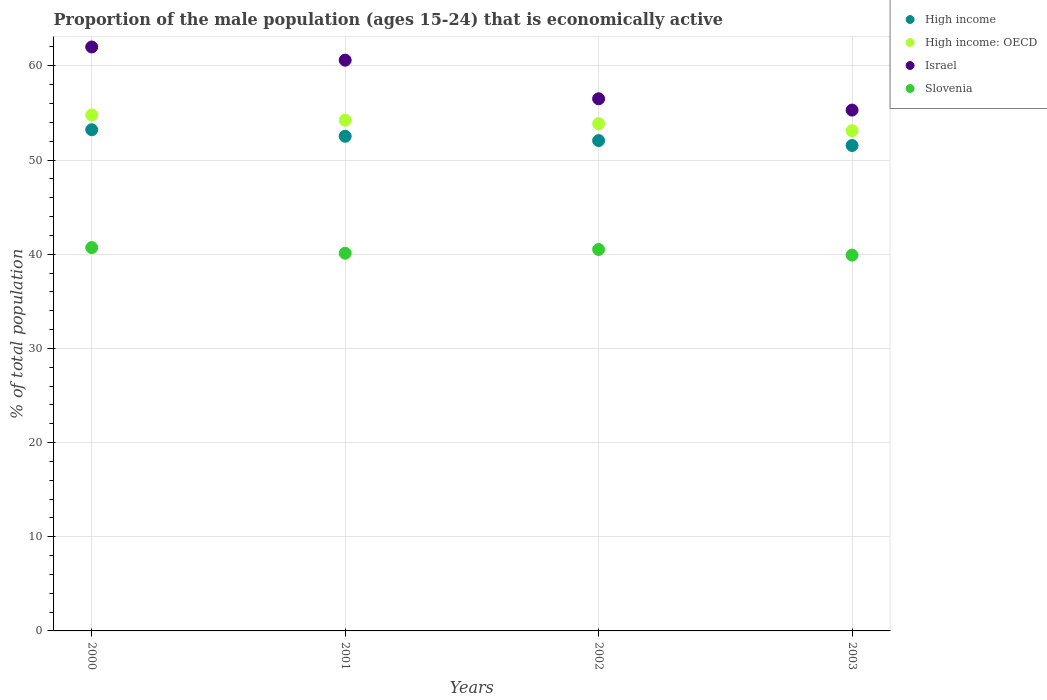Is the number of dotlines equal to the number of legend labels?
Your response must be concise. Yes. What is the proportion of the male population that is economically active in High income in 2001?
Provide a succinct answer. 52.52. Across all years, what is the maximum proportion of the male population that is economically active in Slovenia?
Provide a succinct answer. 40.7. Across all years, what is the minimum proportion of the male population that is economically active in Israel?
Give a very brief answer. 55.3. In which year was the proportion of the male population that is economically active in High income: OECD maximum?
Your response must be concise. 2000. In which year was the proportion of the male population that is economically active in High income: OECD minimum?
Your answer should be compact. 2003. What is the total proportion of the male population that is economically active in Israel in the graph?
Your response must be concise. 234.4. What is the difference between the proportion of the male population that is economically active in Israel in 2001 and that in 2003?
Your answer should be very brief. 5.3. What is the difference between the proportion of the male population that is economically active in High income in 2002 and the proportion of the male population that is economically active in High income: OECD in 2000?
Offer a very short reply. -2.72. What is the average proportion of the male population that is economically active in Slovenia per year?
Provide a short and direct response. 40.3. In the year 2000, what is the difference between the proportion of the male population that is economically active in Slovenia and proportion of the male population that is economically active in High income?
Ensure brevity in your answer.  -12.51. In how many years, is the proportion of the male population that is economically active in High income greater than 30 %?
Offer a terse response. 4. What is the ratio of the proportion of the male population that is economically active in Slovenia in 2000 to that in 2002?
Make the answer very short. 1. What is the difference between the highest and the second highest proportion of the male population that is economically active in High income?
Keep it short and to the point. 0.69. What is the difference between the highest and the lowest proportion of the male population that is economically active in Slovenia?
Offer a terse response. 0.8. In how many years, is the proportion of the male population that is economically active in Israel greater than the average proportion of the male population that is economically active in Israel taken over all years?
Ensure brevity in your answer.  2. Is it the case that in every year, the sum of the proportion of the male population that is economically active in High income: OECD and proportion of the male population that is economically active in Israel  is greater than the proportion of the male population that is economically active in Slovenia?
Make the answer very short. Yes. Is the proportion of the male population that is economically active in High income strictly less than the proportion of the male population that is economically active in Slovenia over the years?
Ensure brevity in your answer.  No. How many dotlines are there?
Give a very brief answer. 4. How many years are there in the graph?
Provide a short and direct response. 4. What is the difference between two consecutive major ticks on the Y-axis?
Ensure brevity in your answer.  10. What is the title of the graph?
Keep it short and to the point. Proportion of the male population (ages 15-24) that is economically active. Does "Philippines" appear as one of the legend labels in the graph?
Provide a succinct answer. No. What is the label or title of the Y-axis?
Provide a succinct answer. % of total population. What is the % of total population of High income in 2000?
Offer a very short reply. 53.21. What is the % of total population in High income: OECD in 2000?
Make the answer very short. 54.78. What is the % of total population in Slovenia in 2000?
Your answer should be compact. 40.7. What is the % of total population of High income in 2001?
Offer a very short reply. 52.52. What is the % of total population in High income: OECD in 2001?
Offer a very short reply. 54.23. What is the % of total population of Israel in 2001?
Offer a very short reply. 60.6. What is the % of total population in Slovenia in 2001?
Ensure brevity in your answer.  40.1. What is the % of total population of High income in 2002?
Provide a succinct answer. 52.06. What is the % of total population in High income: OECD in 2002?
Give a very brief answer. 53.86. What is the % of total population of Israel in 2002?
Give a very brief answer. 56.5. What is the % of total population of Slovenia in 2002?
Your answer should be compact. 40.5. What is the % of total population of High income in 2003?
Give a very brief answer. 51.54. What is the % of total population in High income: OECD in 2003?
Offer a terse response. 53.11. What is the % of total population in Israel in 2003?
Give a very brief answer. 55.3. What is the % of total population of Slovenia in 2003?
Your answer should be compact. 39.9. Across all years, what is the maximum % of total population of High income?
Ensure brevity in your answer.  53.21. Across all years, what is the maximum % of total population in High income: OECD?
Offer a very short reply. 54.78. Across all years, what is the maximum % of total population in Slovenia?
Your answer should be compact. 40.7. Across all years, what is the minimum % of total population of High income?
Your answer should be compact. 51.54. Across all years, what is the minimum % of total population of High income: OECD?
Your response must be concise. 53.11. Across all years, what is the minimum % of total population in Israel?
Your answer should be compact. 55.3. Across all years, what is the minimum % of total population of Slovenia?
Your response must be concise. 39.9. What is the total % of total population of High income in the graph?
Provide a short and direct response. 209.34. What is the total % of total population of High income: OECD in the graph?
Provide a succinct answer. 215.98. What is the total % of total population of Israel in the graph?
Your response must be concise. 234.4. What is the total % of total population of Slovenia in the graph?
Offer a very short reply. 161.2. What is the difference between the % of total population in High income in 2000 and that in 2001?
Offer a very short reply. 0.69. What is the difference between the % of total population in High income: OECD in 2000 and that in 2001?
Your answer should be very brief. 0.55. What is the difference between the % of total population in Slovenia in 2000 and that in 2001?
Ensure brevity in your answer.  0.6. What is the difference between the % of total population in High income in 2000 and that in 2002?
Provide a succinct answer. 1.15. What is the difference between the % of total population of High income: OECD in 2000 and that in 2002?
Your response must be concise. 0.92. What is the difference between the % of total population in Israel in 2000 and that in 2002?
Your answer should be very brief. 5.5. What is the difference between the % of total population in Slovenia in 2000 and that in 2002?
Your response must be concise. 0.2. What is the difference between the % of total population in High income in 2000 and that in 2003?
Keep it short and to the point. 1.67. What is the difference between the % of total population in High income: OECD in 2000 and that in 2003?
Keep it short and to the point. 1.67. What is the difference between the % of total population in High income in 2001 and that in 2002?
Offer a very short reply. 0.46. What is the difference between the % of total population in High income: OECD in 2001 and that in 2002?
Your answer should be very brief. 0.37. What is the difference between the % of total population of Israel in 2001 and that in 2002?
Your answer should be compact. 4.1. What is the difference between the % of total population of High income in 2001 and that in 2003?
Make the answer very short. 0.98. What is the difference between the % of total population in High income: OECD in 2001 and that in 2003?
Provide a short and direct response. 1.12. What is the difference between the % of total population in Slovenia in 2001 and that in 2003?
Ensure brevity in your answer.  0.2. What is the difference between the % of total population in High income in 2002 and that in 2003?
Your answer should be very brief. 0.52. What is the difference between the % of total population of High income: OECD in 2002 and that in 2003?
Provide a short and direct response. 0.75. What is the difference between the % of total population of High income in 2000 and the % of total population of High income: OECD in 2001?
Your response must be concise. -1.02. What is the difference between the % of total population of High income in 2000 and the % of total population of Israel in 2001?
Your answer should be compact. -7.39. What is the difference between the % of total population of High income in 2000 and the % of total population of Slovenia in 2001?
Keep it short and to the point. 13.11. What is the difference between the % of total population of High income: OECD in 2000 and the % of total population of Israel in 2001?
Your answer should be compact. -5.82. What is the difference between the % of total population of High income: OECD in 2000 and the % of total population of Slovenia in 2001?
Your answer should be very brief. 14.68. What is the difference between the % of total population of Israel in 2000 and the % of total population of Slovenia in 2001?
Keep it short and to the point. 21.9. What is the difference between the % of total population of High income in 2000 and the % of total population of High income: OECD in 2002?
Keep it short and to the point. -0.65. What is the difference between the % of total population in High income in 2000 and the % of total population in Israel in 2002?
Your answer should be very brief. -3.29. What is the difference between the % of total population in High income in 2000 and the % of total population in Slovenia in 2002?
Your answer should be compact. 12.71. What is the difference between the % of total population of High income: OECD in 2000 and the % of total population of Israel in 2002?
Your answer should be compact. -1.72. What is the difference between the % of total population in High income: OECD in 2000 and the % of total population in Slovenia in 2002?
Provide a succinct answer. 14.28. What is the difference between the % of total population of Israel in 2000 and the % of total population of Slovenia in 2002?
Give a very brief answer. 21.5. What is the difference between the % of total population of High income in 2000 and the % of total population of High income: OECD in 2003?
Offer a terse response. 0.1. What is the difference between the % of total population in High income in 2000 and the % of total population in Israel in 2003?
Make the answer very short. -2.09. What is the difference between the % of total population in High income in 2000 and the % of total population in Slovenia in 2003?
Provide a succinct answer. 13.31. What is the difference between the % of total population in High income: OECD in 2000 and the % of total population in Israel in 2003?
Provide a short and direct response. -0.52. What is the difference between the % of total population of High income: OECD in 2000 and the % of total population of Slovenia in 2003?
Your answer should be compact. 14.88. What is the difference between the % of total population of Israel in 2000 and the % of total population of Slovenia in 2003?
Offer a very short reply. 22.1. What is the difference between the % of total population in High income in 2001 and the % of total population in High income: OECD in 2002?
Provide a short and direct response. -1.34. What is the difference between the % of total population in High income in 2001 and the % of total population in Israel in 2002?
Provide a short and direct response. -3.98. What is the difference between the % of total population in High income in 2001 and the % of total population in Slovenia in 2002?
Make the answer very short. 12.02. What is the difference between the % of total population of High income: OECD in 2001 and the % of total population of Israel in 2002?
Provide a succinct answer. -2.27. What is the difference between the % of total population of High income: OECD in 2001 and the % of total population of Slovenia in 2002?
Provide a short and direct response. 13.73. What is the difference between the % of total population of Israel in 2001 and the % of total population of Slovenia in 2002?
Provide a short and direct response. 20.1. What is the difference between the % of total population of High income in 2001 and the % of total population of High income: OECD in 2003?
Provide a short and direct response. -0.59. What is the difference between the % of total population in High income in 2001 and the % of total population in Israel in 2003?
Provide a short and direct response. -2.78. What is the difference between the % of total population of High income in 2001 and the % of total population of Slovenia in 2003?
Your response must be concise. 12.62. What is the difference between the % of total population of High income: OECD in 2001 and the % of total population of Israel in 2003?
Your response must be concise. -1.07. What is the difference between the % of total population of High income: OECD in 2001 and the % of total population of Slovenia in 2003?
Keep it short and to the point. 14.33. What is the difference between the % of total population in Israel in 2001 and the % of total population in Slovenia in 2003?
Your response must be concise. 20.7. What is the difference between the % of total population in High income in 2002 and the % of total population in High income: OECD in 2003?
Give a very brief answer. -1.05. What is the difference between the % of total population of High income in 2002 and the % of total population of Israel in 2003?
Make the answer very short. -3.24. What is the difference between the % of total population in High income in 2002 and the % of total population in Slovenia in 2003?
Ensure brevity in your answer.  12.16. What is the difference between the % of total population in High income: OECD in 2002 and the % of total population in Israel in 2003?
Ensure brevity in your answer.  -1.44. What is the difference between the % of total population in High income: OECD in 2002 and the % of total population in Slovenia in 2003?
Provide a succinct answer. 13.96. What is the average % of total population in High income per year?
Offer a terse response. 52.33. What is the average % of total population of High income: OECD per year?
Provide a succinct answer. 54. What is the average % of total population in Israel per year?
Provide a succinct answer. 58.6. What is the average % of total population in Slovenia per year?
Your answer should be very brief. 40.3. In the year 2000, what is the difference between the % of total population in High income and % of total population in High income: OECD?
Offer a terse response. -1.57. In the year 2000, what is the difference between the % of total population of High income and % of total population of Israel?
Your answer should be very brief. -8.79. In the year 2000, what is the difference between the % of total population of High income and % of total population of Slovenia?
Offer a very short reply. 12.51. In the year 2000, what is the difference between the % of total population in High income: OECD and % of total population in Israel?
Give a very brief answer. -7.22. In the year 2000, what is the difference between the % of total population of High income: OECD and % of total population of Slovenia?
Your answer should be very brief. 14.08. In the year 2000, what is the difference between the % of total population in Israel and % of total population in Slovenia?
Ensure brevity in your answer.  21.3. In the year 2001, what is the difference between the % of total population in High income and % of total population in High income: OECD?
Your answer should be very brief. -1.71. In the year 2001, what is the difference between the % of total population in High income and % of total population in Israel?
Offer a very short reply. -8.08. In the year 2001, what is the difference between the % of total population in High income and % of total population in Slovenia?
Your response must be concise. 12.42. In the year 2001, what is the difference between the % of total population of High income: OECD and % of total population of Israel?
Your answer should be compact. -6.37. In the year 2001, what is the difference between the % of total population in High income: OECD and % of total population in Slovenia?
Your response must be concise. 14.13. In the year 2002, what is the difference between the % of total population of High income and % of total population of High income: OECD?
Offer a terse response. -1.8. In the year 2002, what is the difference between the % of total population of High income and % of total population of Israel?
Your response must be concise. -4.44. In the year 2002, what is the difference between the % of total population in High income and % of total population in Slovenia?
Your response must be concise. 11.56. In the year 2002, what is the difference between the % of total population of High income: OECD and % of total population of Israel?
Your answer should be compact. -2.64. In the year 2002, what is the difference between the % of total population of High income: OECD and % of total population of Slovenia?
Your answer should be compact. 13.36. In the year 2003, what is the difference between the % of total population of High income and % of total population of High income: OECD?
Make the answer very short. -1.57. In the year 2003, what is the difference between the % of total population in High income and % of total population in Israel?
Make the answer very short. -3.76. In the year 2003, what is the difference between the % of total population of High income and % of total population of Slovenia?
Ensure brevity in your answer.  11.64. In the year 2003, what is the difference between the % of total population of High income: OECD and % of total population of Israel?
Give a very brief answer. -2.19. In the year 2003, what is the difference between the % of total population in High income: OECD and % of total population in Slovenia?
Your response must be concise. 13.21. In the year 2003, what is the difference between the % of total population of Israel and % of total population of Slovenia?
Provide a succinct answer. 15.4. What is the ratio of the % of total population in High income in 2000 to that in 2001?
Your answer should be compact. 1.01. What is the ratio of the % of total population in Israel in 2000 to that in 2001?
Ensure brevity in your answer.  1.02. What is the ratio of the % of total population in High income in 2000 to that in 2002?
Your answer should be very brief. 1.02. What is the ratio of the % of total population in High income: OECD in 2000 to that in 2002?
Make the answer very short. 1.02. What is the ratio of the % of total population in Israel in 2000 to that in 2002?
Keep it short and to the point. 1.1. What is the ratio of the % of total population of Slovenia in 2000 to that in 2002?
Keep it short and to the point. 1. What is the ratio of the % of total population of High income in 2000 to that in 2003?
Provide a succinct answer. 1.03. What is the ratio of the % of total population in High income: OECD in 2000 to that in 2003?
Provide a succinct answer. 1.03. What is the ratio of the % of total population in Israel in 2000 to that in 2003?
Give a very brief answer. 1.12. What is the ratio of the % of total population in Slovenia in 2000 to that in 2003?
Provide a short and direct response. 1.02. What is the ratio of the % of total population in High income in 2001 to that in 2002?
Your answer should be very brief. 1.01. What is the ratio of the % of total population of High income: OECD in 2001 to that in 2002?
Provide a short and direct response. 1.01. What is the ratio of the % of total population of Israel in 2001 to that in 2002?
Your answer should be very brief. 1.07. What is the ratio of the % of total population of Israel in 2001 to that in 2003?
Your answer should be very brief. 1.1. What is the ratio of the % of total population of High income: OECD in 2002 to that in 2003?
Provide a succinct answer. 1.01. What is the ratio of the % of total population in Israel in 2002 to that in 2003?
Provide a short and direct response. 1.02. What is the ratio of the % of total population of Slovenia in 2002 to that in 2003?
Ensure brevity in your answer.  1.01. What is the difference between the highest and the second highest % of total population of High income?
Keep it short and to the point. 0.69. What is the difference between the highest and the second highest % of total population of High income: OECD?
Your response must be concise. 0.55. What is the difference between the highest and the lowest % of total population of High income?
Your response must be concise. 1.67. What is the difference between the highest and the lowest % of total population of High income: OECD?
Provide a succinct answer. 1.67. What is the difference between the highest and the lowest % of total population of Israel?
Provide a short and direct response. 6.7. 